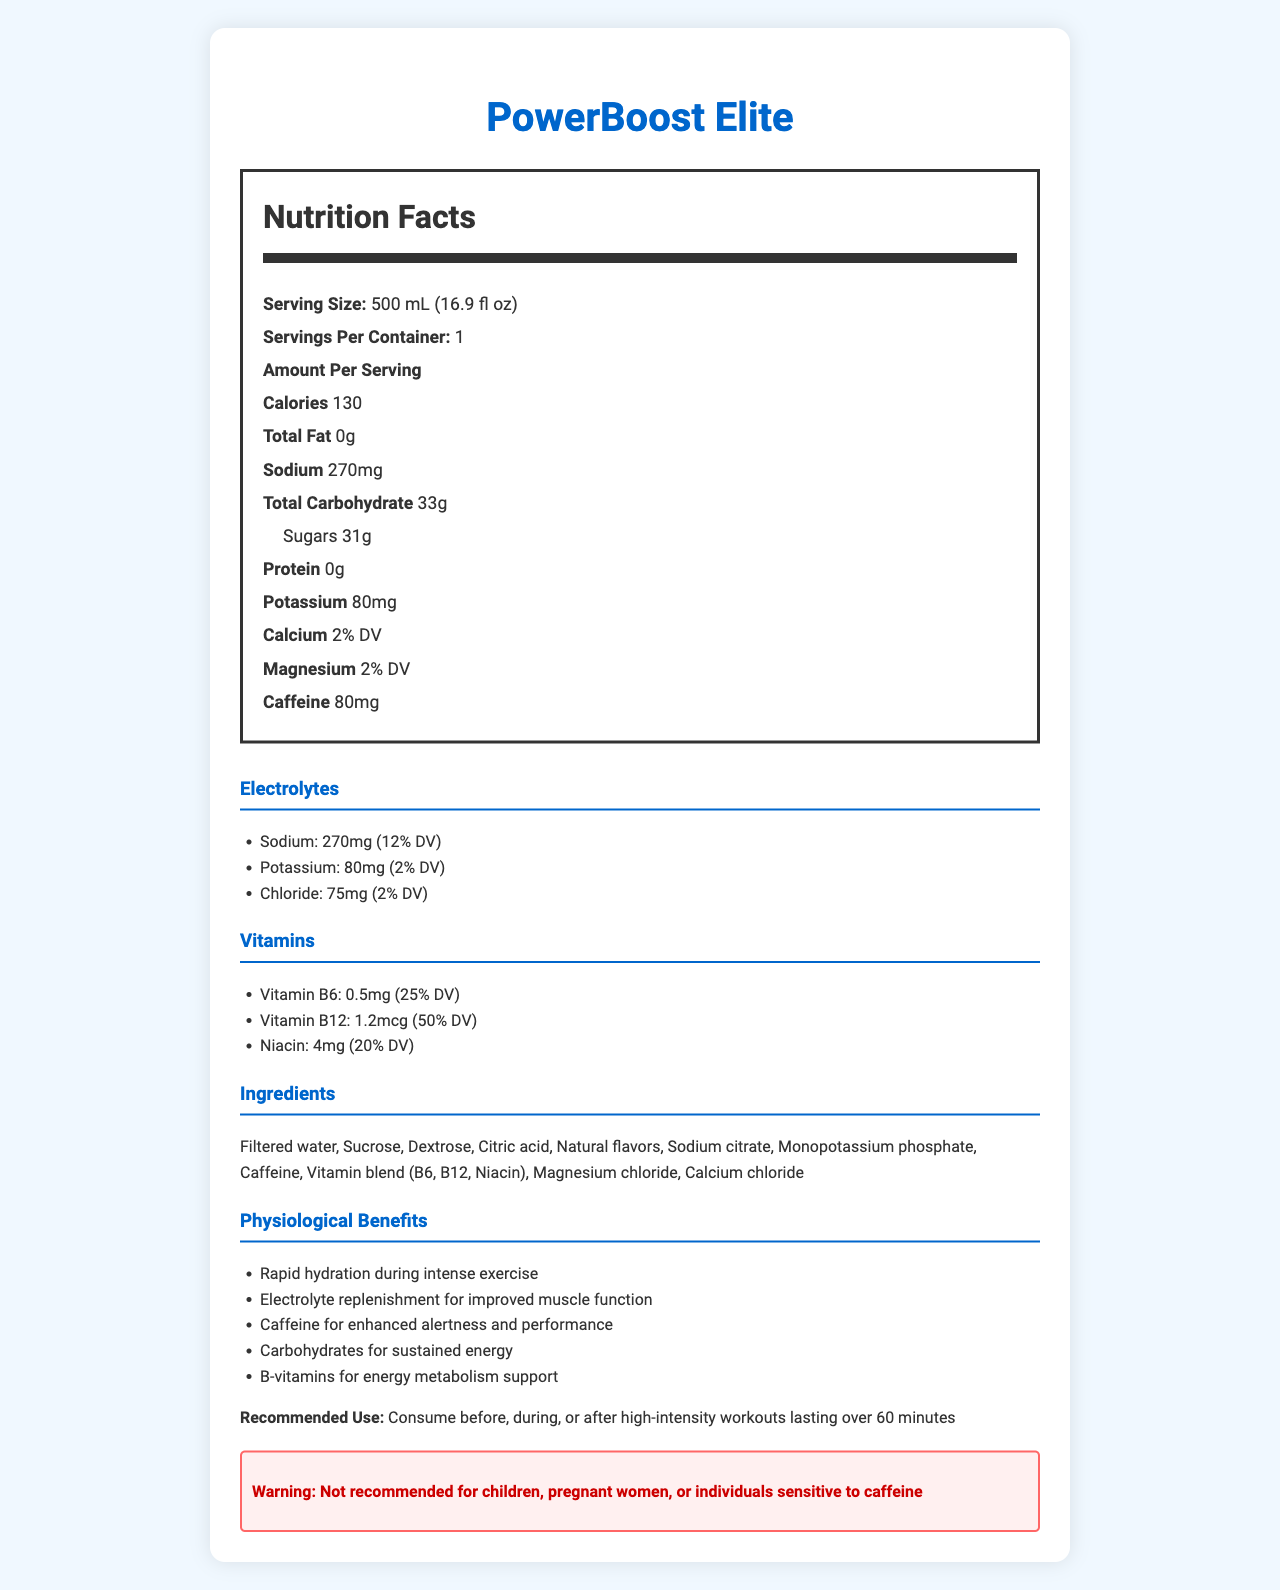What is the serving size for PowerBoost Elite? The serving size is clearly listed under the nutrition facts section.
Answer: 500 mL (16.9 fl oz) How many calories are in one serving of PowerBoost Elite? The nutrition label lists the amount of calories per serving.
Answer: 130 calories What is the amount of caffeine in PowerBoost Elite? The nutrition facts label specifies the caffeine content as 80mg per serving.
Answer: 80mg What percentage of the daily value is Vitamin B12 in PowerBoost Elite? The vitamins section lists the percentage daily value of Vitamin B12.
Answer: 50% DV Name one of the physiological benefits of consuming PowerBoost Elite. The physiological benefits section lists various benefits, including rapid hydration during intense exercise.
Answer: Rapid hydration during intense exercise Which of the following electrolytes is present in the highest amount in PowerBoost Elite? A. Chloride B. Sodium C. Potassium D. Calcium The amounts of electrolytes are listed under the electrolytes section, with Sodium having the highest content at 270mg.
Answer: B. Sodium From the ingredients list, which one is identified as providing caffeine? A. Sodium citrate B. Natural flavors C. Caffeine D. Vitamin blend (B6, B12, Niacin) The list of ingredients indicates that caffeine is present in the product.
Answer: C. Caffeine Is PowerBoost Elite recommended for children? Yes/No The warning section states that the product is not recommended for children.
Answer: No Summarize the main idea of the document. The document details the nutrition facts, ingredients, physiological benefits, recommended use, and a warning concerning the product.
Answer: PowerBoost Elite is a sports drink with various nutrients, including electrolytes and vitamins, designed to provide physiological benefits such as rapid hydration, improved muscle function, and enhanced alertness. It contains caffeine and is advised for use during high-intensity workouts. What is the specific amount of Magnesium in PowerBoost Elite? The document lists Magnesium as 2% DV but does not specify its exact amount in milligrams.
Answer: Not enough information How many grams of sugars are in one serving of PowerBoost Elite? The nutrition label specifies the sugar content as 31g per serving.
Answer: 31g What is the recommended use for PowerBoost Elite? The recommended use section clearly states when to consume the product.
Answer: Consume before, during, or after high-intensity workouts lasting over 60 minutes What type of sweeteners are included in PowerBoost Elite? The ingredients list includes both Sucrose and Dextrose as sweeteners.
Answer: Sucrose and Dextrose 